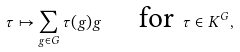Convert formula to latex. <formula><loc_0><loc_0><loc_500><loc_500>\tau \mapsto \sum _ { g \in G } \tau ( g ) g \quad \text { for } \tau \in K ^ { G } ,</formula> 